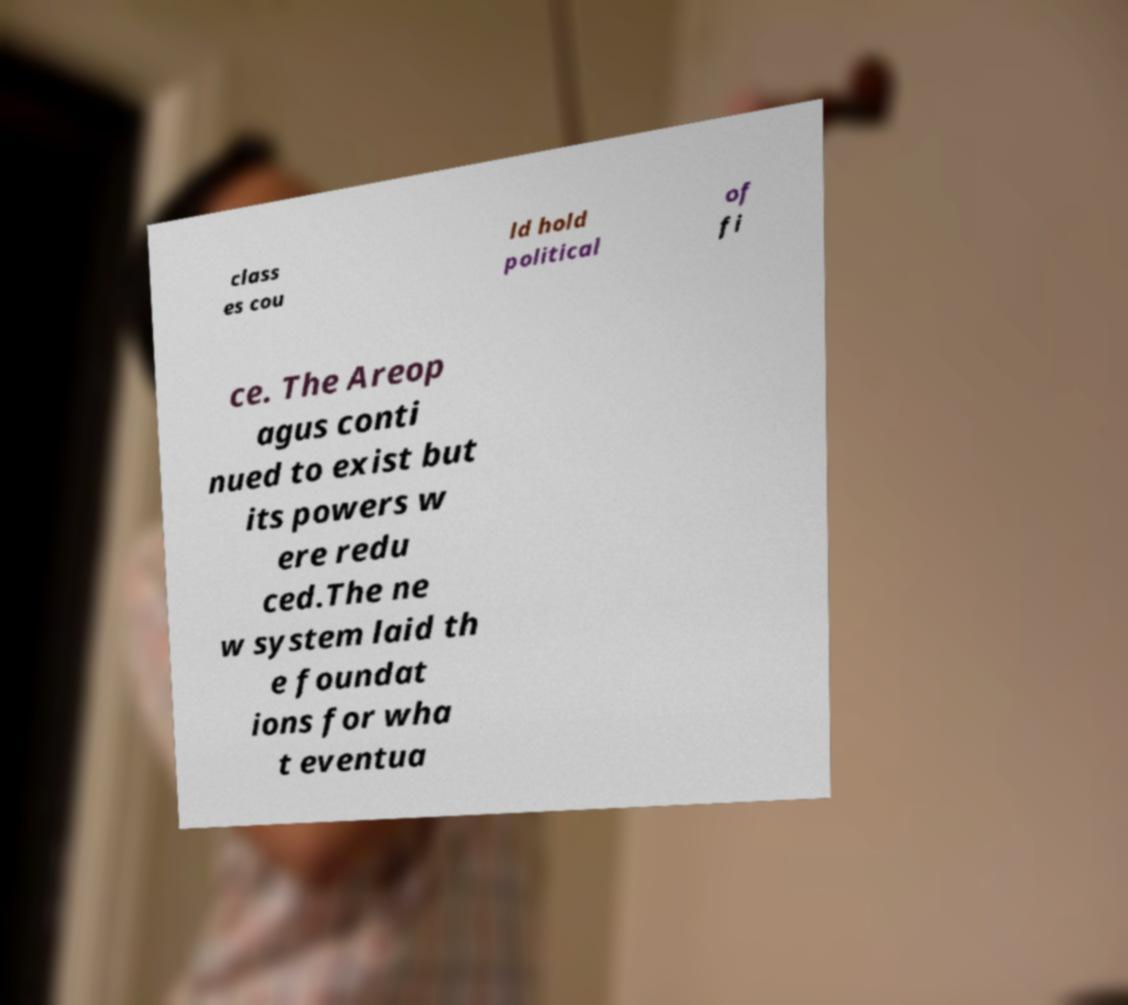I need the written content from this picture converted into text. Can you do that? class es cou ld hold political of fi ce. The Areop agus conti nued to exist but its powers w ere redu ced.The ne w system laid th e foundat ions for wha t eventua 